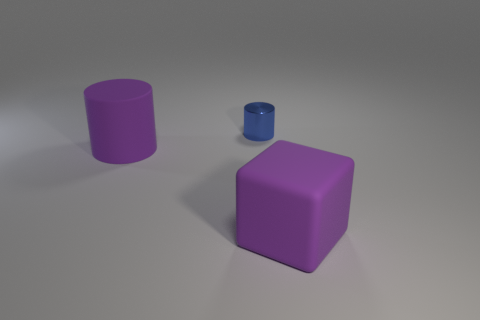Add 3 small yellow metal balls. How many objects exist? 6 Subtract all cubes. How many objects are left? 2 Add 1 large rubber blocks. How many large rubber blocks are left? 2 Add 2 large rubber cylinders. How many large rubber cylinders exist? 3 Subtract 1 purple cubes. How many objects are left? 2 Subtract all tiny blue metal cylinders. Subtract all purple cylinders. How many objects are left? 1 